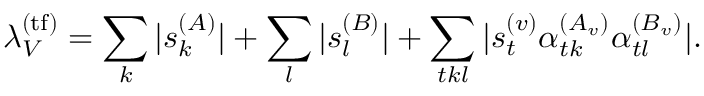Convert formula to latex. <formula><loc_0><loc_0><loc_500><loc_500>\lambda _ { V } ^ { ( t f ) } = \sum _ { k } | s _ { k } ^ { ( A ) } | + \sum _ { l } | s _ { l } ^ { ( B ) } | + \sum _ { t k l } | s _ { t } ^ { ( v ) } \alpha _ { t k } ^ { ( A _ { v } ) } \alpha _ { t l } ^ { ( B _ { v } ) } | .</formula> 